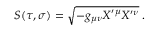<formula> <loc_0><loc_0><loc_500><loc_500>S ( \tau , \sigma ) = \sqrt { - g _ { \mu \nu } X ^ { \prime \mu } X ^ { \prime \nu } } \, .</formula> 